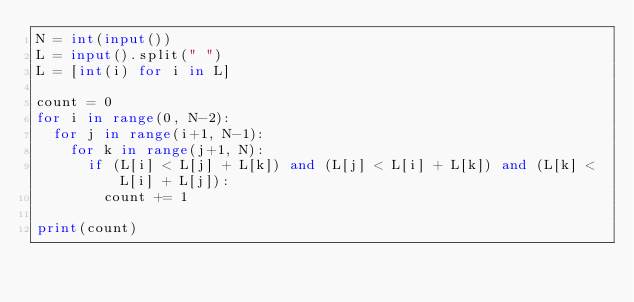Convert code to text. <code><loc_0><loc_0><loc_500><loc_500><_Python_>N = int(input())
L = input().split(" ")
L = [int(i) for i in L]

count = 0
for i in range(0, N-2):
  for j in range(i+1, N-1):
    for k in range(j+1, N):
      if (L[i] < L[j] + L[k]) and (L[j] < L[i] + L[k]) and (L[k] < L[i] + L[j]):
        count += 1

print(count)</code> 